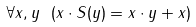Convert formula to latex. <formula><loc_0><loc_0><loc_500><loc_500>\forall x , y \ ( x \cdot S ( y ) = x \cdot y + x )</formula> 